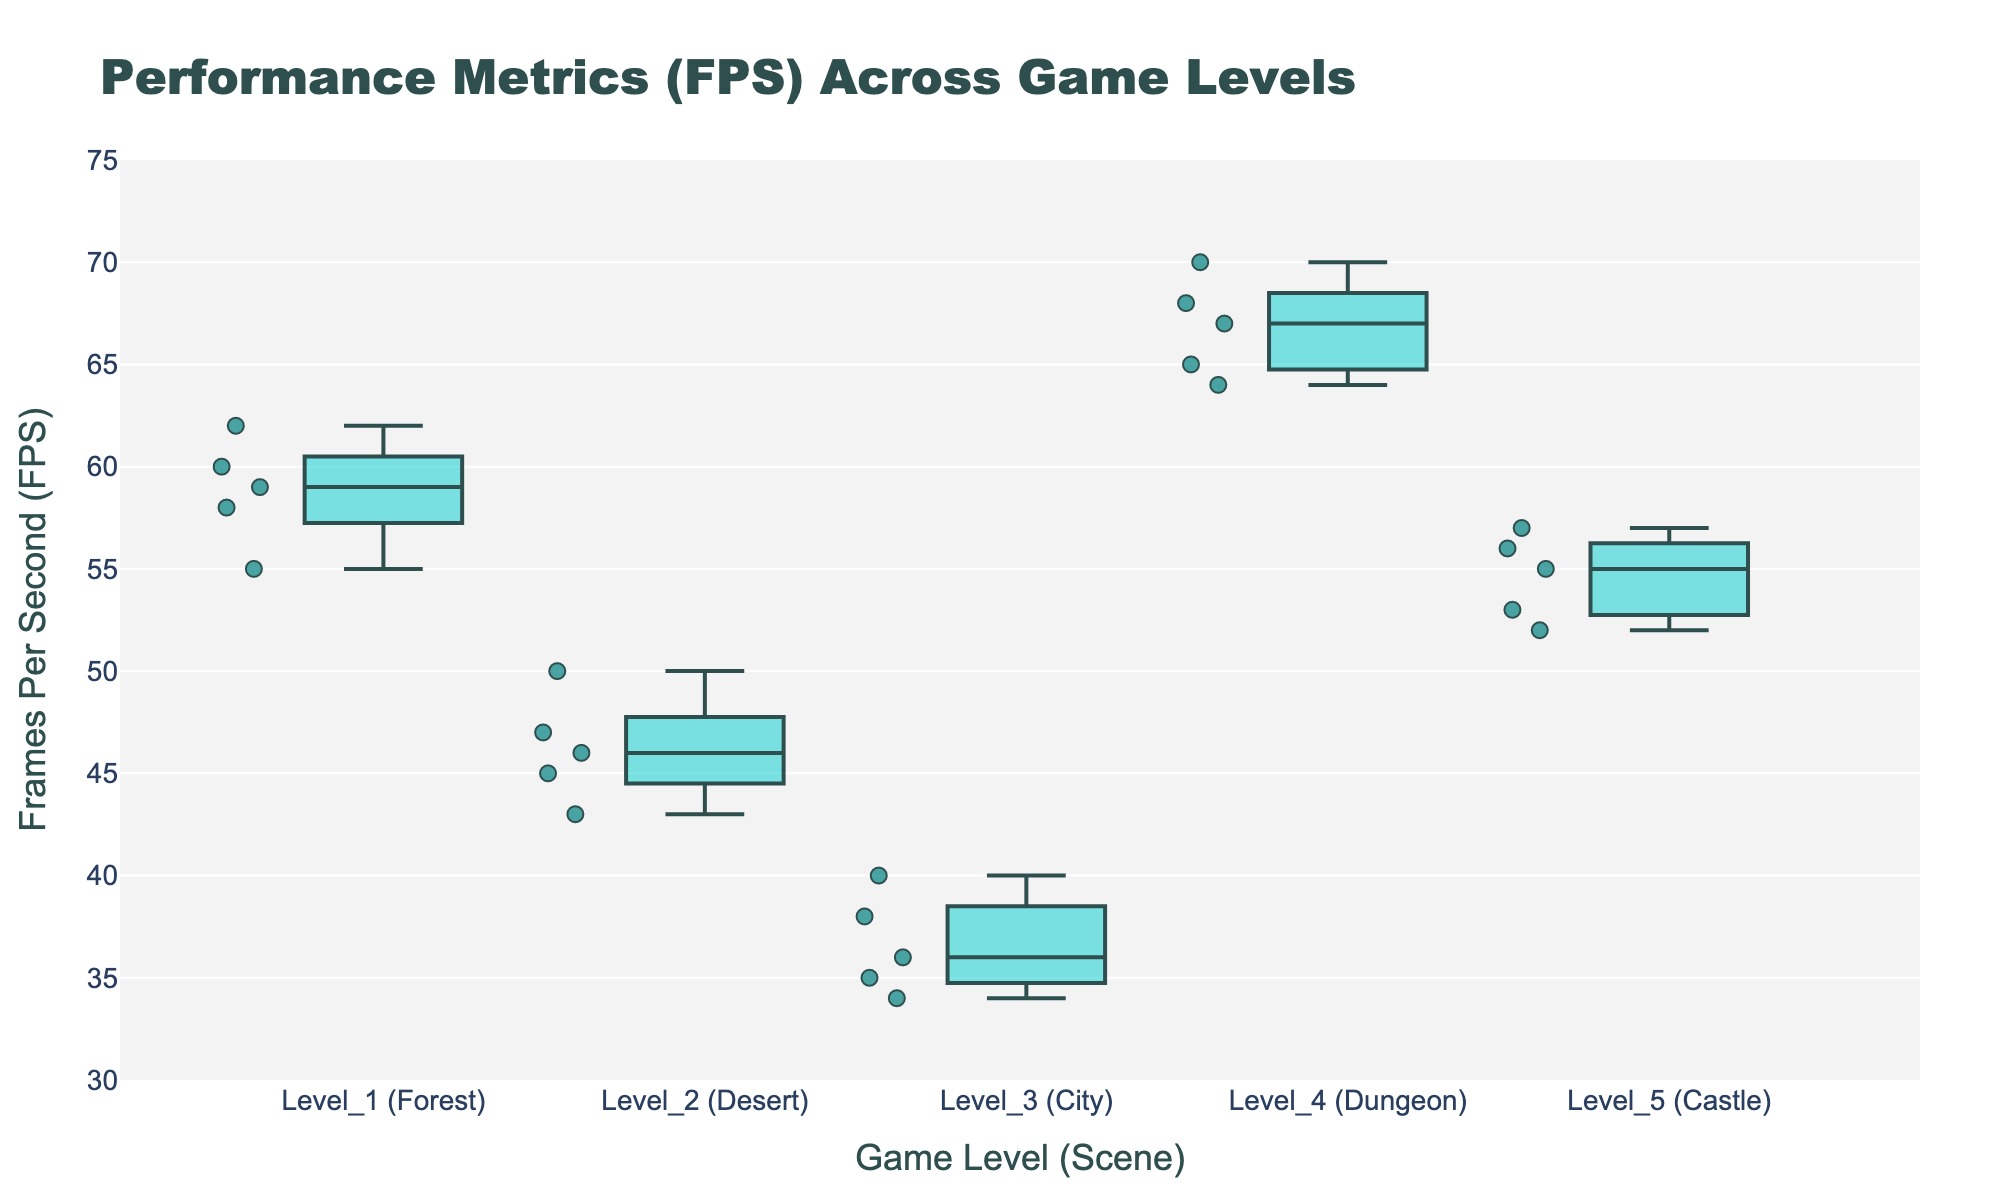Which game level has the highest FPS? Observing the figure, the boxplot for Level 4 (Dungeon) stands noticeably higher on the y-axis compared to others, indicating it has the highest FPS range.
Answer: Level 4 (Dungeon) What is the range of FPS in Level 3 (City)? The range of FPS is the difference between the largest and smallest values. For Level 3 (City), the whiskers extend from approximately 34 to 40 FPS. So, 40 - 34 = 6.
Answer: 6 Which level has the most variability in FPS? Variability is indicated by the interquartile range (IQR). Level 2 (Desert) has the widest IQR, with a larger spread between the lower and upper quartiles compared to other levels.
Answer: Level 2 (Desert) Is the median FPS higher in Level 1 (Forest) or Level 5 (Castle)? We can identify the median by looking at the line within each boxplot. The median for Level 1 (Forest) appears to be around 59 FPS, while Level 5 (Castle) is around 55 FPS. Therefore, the median is higher in Level 1 (Forest).
Answer: Level 1 (Forest) What is the interquartile range (IQR) of FPS in Level 5 (Castle)? The IQR is the difference between the third quartile (Q3) and the first quartile (Q1). For Level 5 (Castle), Q3 is approximately 56 and Q1 is around 53. Thus, 56 - 53 = 3.
Answer: 3 How does the FPS in Level 2 (Desert) compare to the FPS in Level 1 (Forest)? Comparing the median lines in the box plots, the median FPS for Level 2 (Desert) is lower, around 46 FPS, compared to Level 1 (Forest), which is around 59 FPS.
Answer: Level 2 is lower Which levels have outliers in FPS? Outliers are points that lie beyond the whiskers of the box plot. By examining the figure, outliers can be seen in Level 2 (Desert) and Level 3 (City).
Answer: Level 2 and Level 3 By how much does the median FPS of Level 4 (Dungeon) exceed the median FPS of Level 3 (City)? The median FPS of Level 4 (Dungeon) appears to be around 67, whereas for Level 3 (City) it is around 36. Thus, 67 - 36 = 31.
Answer: 31 